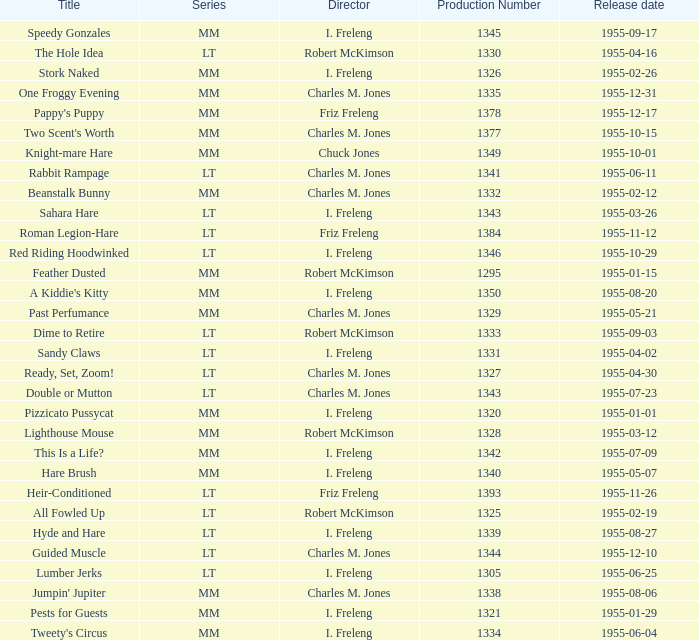What is the title with the production number greater than 1334 released on 1955-08-27? Hyde and Hare. 